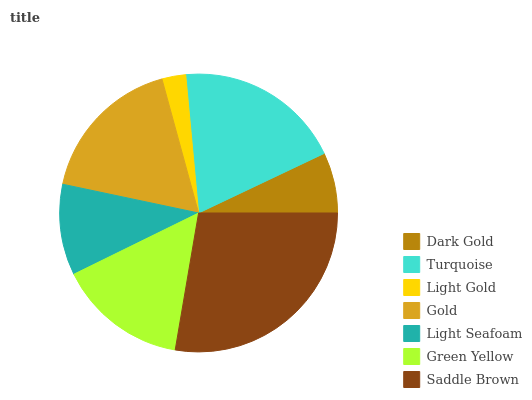Is Light Gold the minimum?
Answer yes or no. Yes. Is Saddle Brown the maximum?
Answer yes or no. Yes. Is Turquoise the minimum?
Answer yes or no. No. Is Turquoise the maximum?
Answer yes or no. No. Is Turquoise greater than Dark Gold?
Answer yes or no. Yes. Is Dark Gold less than Turquoise?
Answer yes or no. Yes. Is Dark Gold greater than Turquoise?
Answer yes or no. No. Is Turquoise less than Dark Gold?
Answer yes or no. No. Is Green Yellow the high median?
Answer yes or no. Yes. Is Green Yellow the low median?
Answer yes or no. Yes. Is Gold the high median?
Answer yes or no. No. Is Saddle Brown the low median?
Answer yes or no. No. 